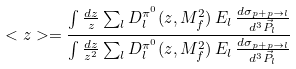<formula> <loc_0><loc_0><loc_500><loc_500>< z > = \frac { \int \frac { d z } { z } \sum _ { l } D _ { l } ^ { \pi ^ { 0 } } ( z , M _ { f } ^ { 2 } ) \, E _ { l } \, \frac { d \sigma _ { p + p \rightarrow l } } { d ^ { 3 } \vec { P } _ { l } } } { \int \frac { d z } { z ^ { 2 } } \sum _ { l } D _ { l } ^ { \pi ^ { 0 } } ( z , M _ { f } ^ { 2 } ) \, E _ { l } \, \frac { d \sigma _ { p + p \rightarrow l } } { d ^ { 3 } \vec { P } _ { l } } }</formula> 